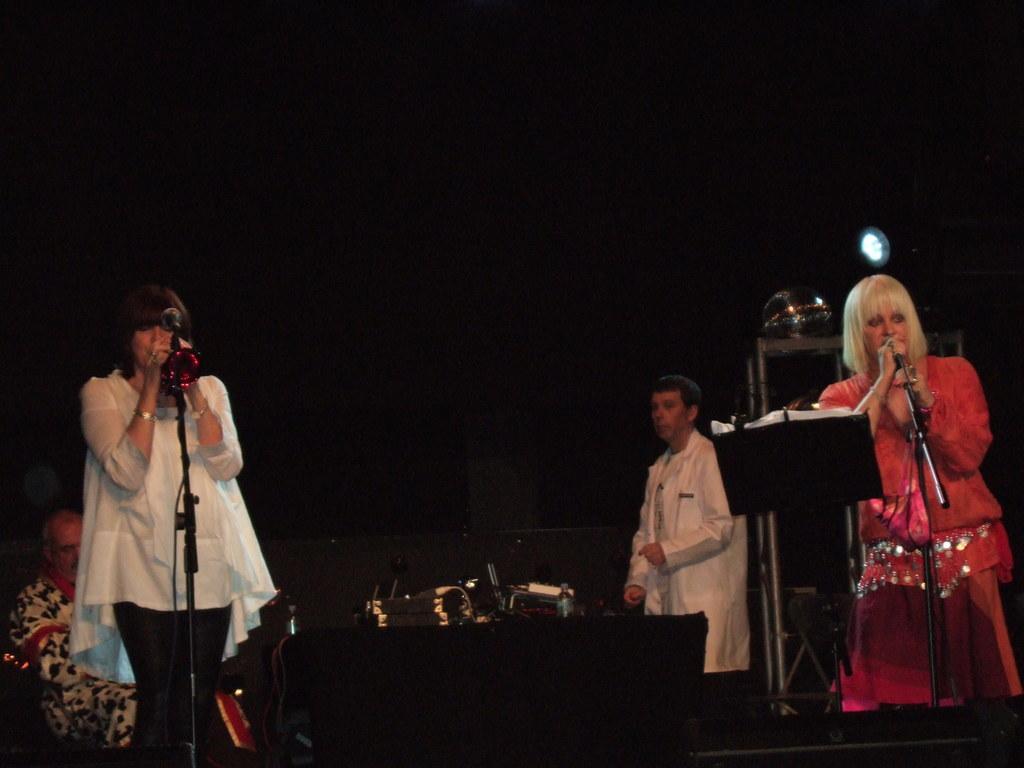How many people are in the image wearing different color dresses? There are people with different color dresses in the image, but the exact number is not specified. What are two people doing in the image? Two people are standing in front of microphones in the image. What is the position of one person in the image? One person is sitting in the image. What color is the background of the image? The background of the image is black. How many visitors are present in the image? There is no mention of visitors in the image, so it is not possible to determine their presence or number. What type of ground is visible in the image? There is no ground visible in the image, as it appears to be an indoor setting with a black background. 